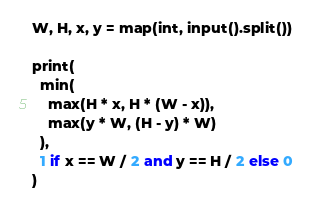<code> <loc_0><loc_0><loc_500><loc_500><_Python_>W, H, x, y = map(int, input().split())

print(
  min(
    max(H * x, H * (W - x)),
    max(y * W, (H - y) * W)
  ),
  1 if x == W / 2 and y == H / 2 else 0
)</code> 